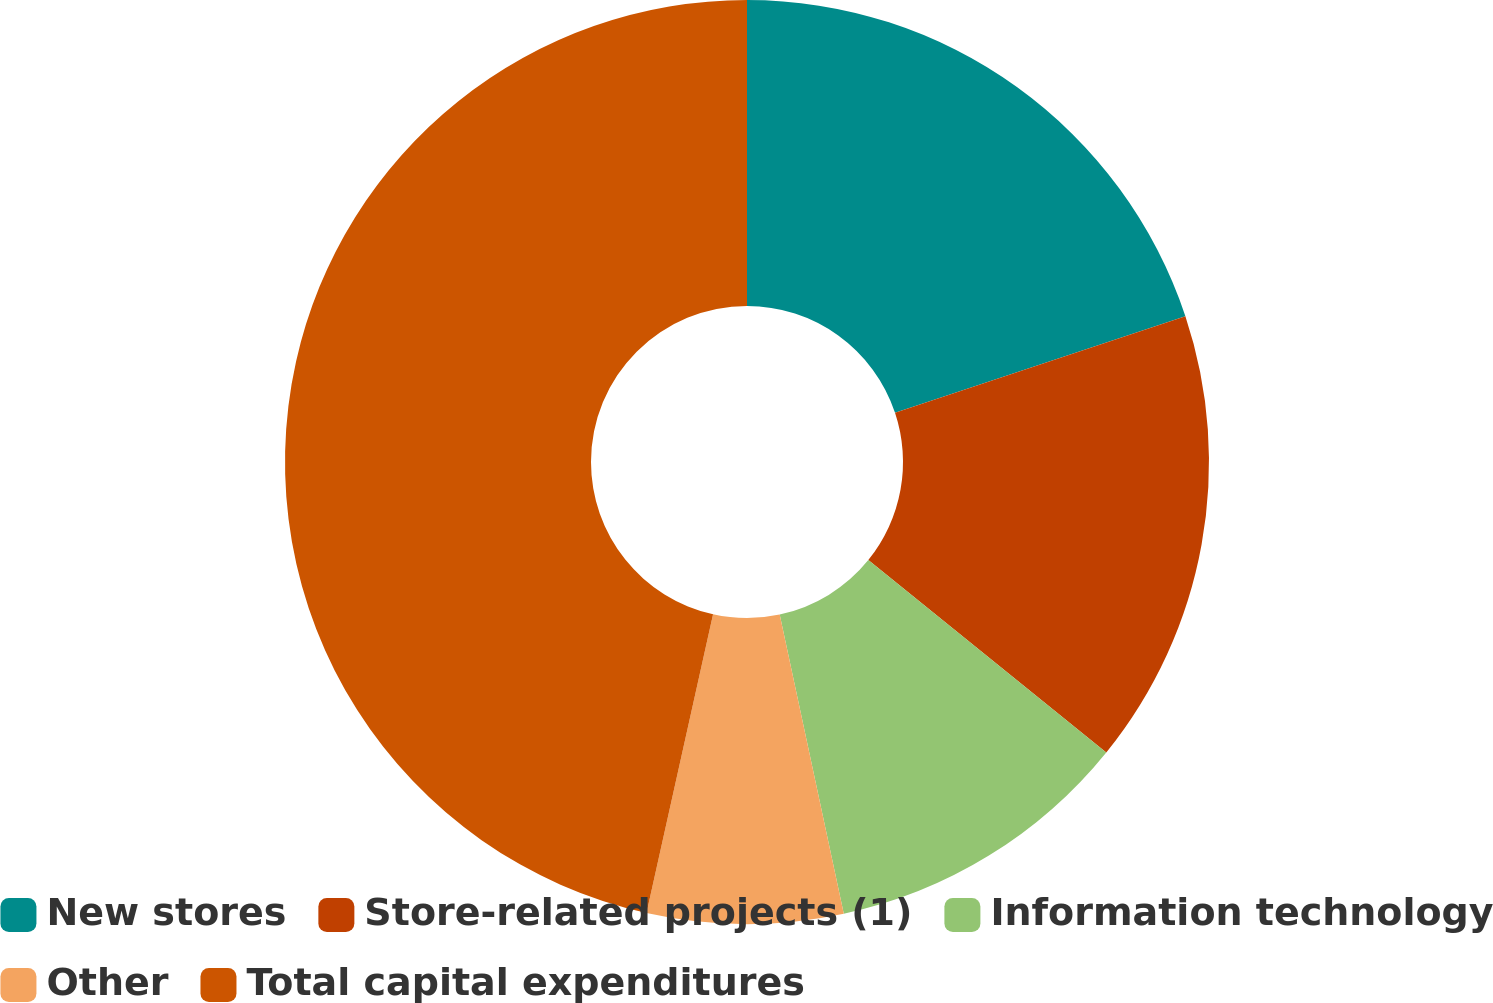Convert chart to OTSL. <chart><loc_0><loc_0><loc_500><loc_500><pie_chart><fcel>New stores<fcel>Store-related projects (1)<fcel>Information technology<fcel>Other<fcel>Total capital expenditures<nl><fcel>19.89%<fcel>15.93%<fcel>10.82%<fcel>6.85%<fcel>46.51%<nl></chart> 